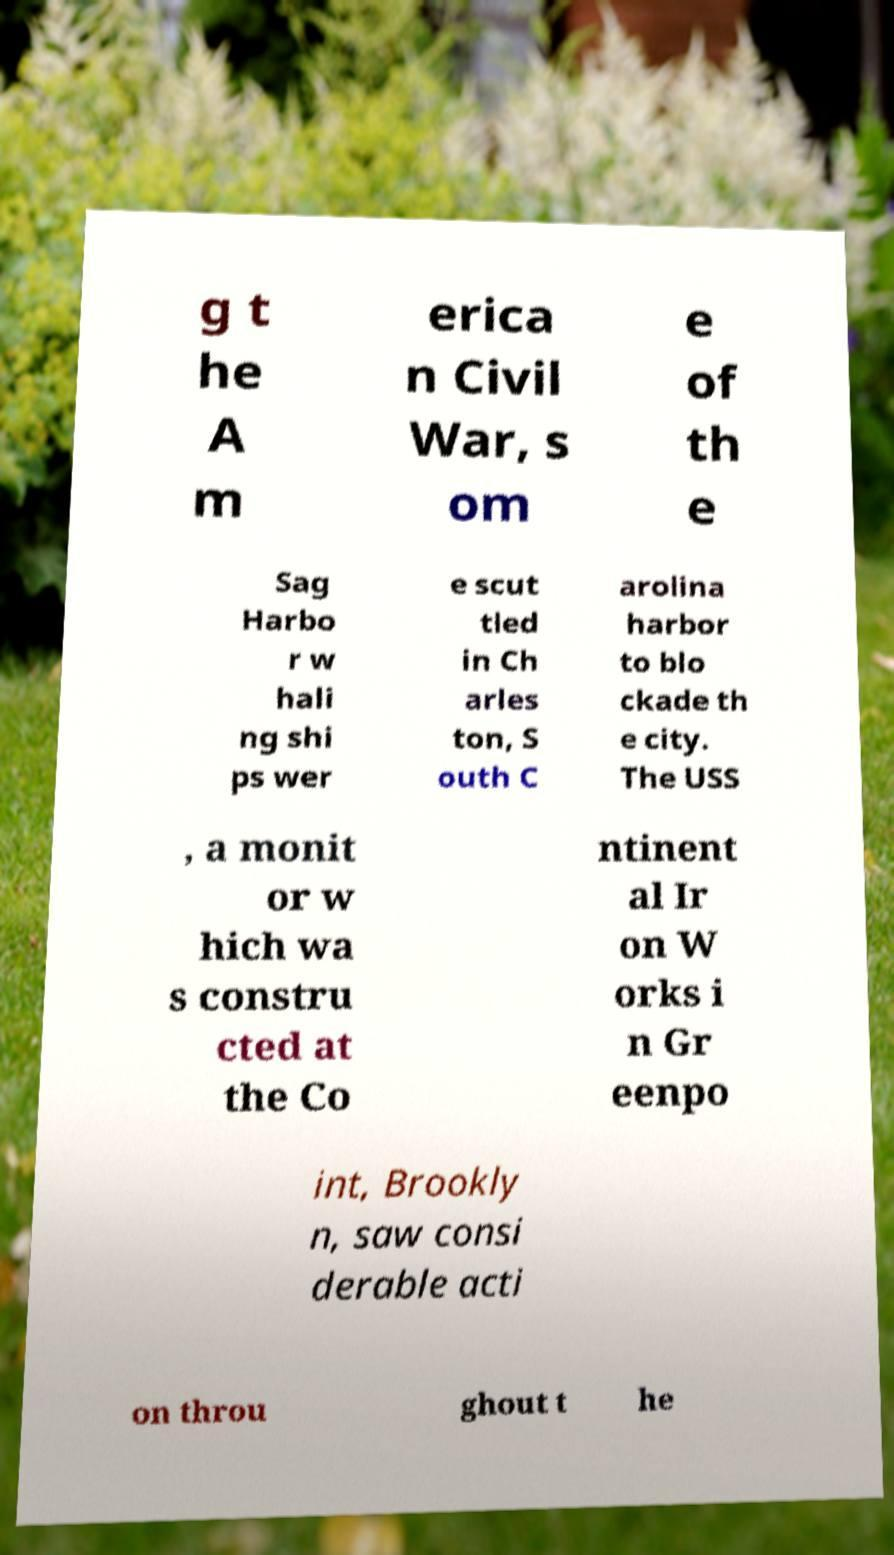Can you read and provide the text displayed in the image?This photo seems to have some interesting text. Can you extract and type it out for me? g t he A m erica n Civil War, s om e of th e Sag Harbo r w hali ng shi ps wer e scut tled in Ch arles ton, S outh C arolina harbor to blo ckade th e city. The USS , a monit or w hich wa s constru cted at the Co ntinent al Ir on W orks i n Gr eenpo int, Brookly n, saw consi derable acti on throu ghout t he 